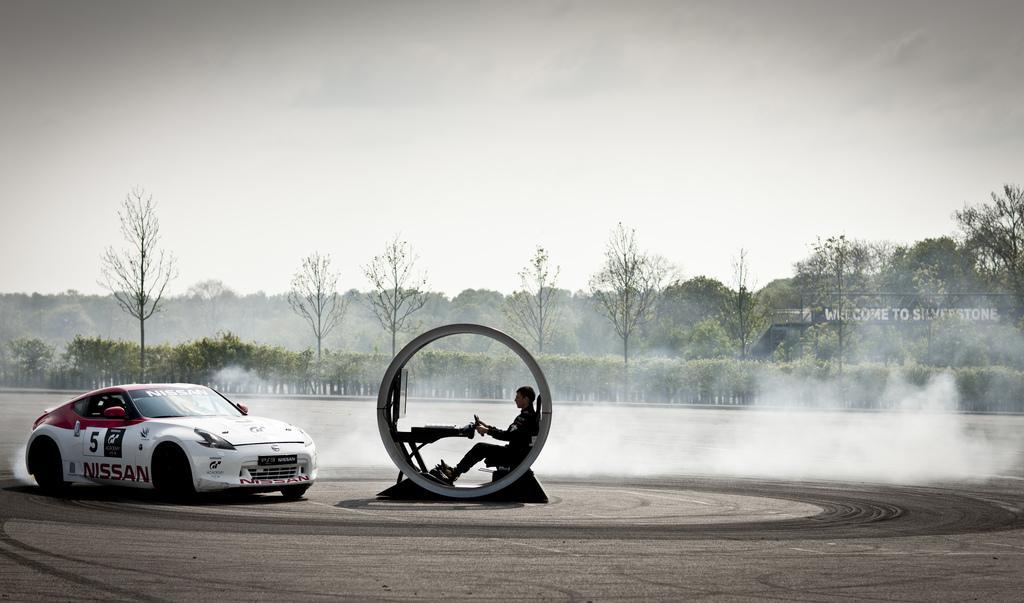How would you summarize this image in a sentence or two? In this image, I can see the man sitting on the seat. This looks like a circular car with a screen, table and steering wheel. This is a car. I can see the trees. I think this is the name board. 